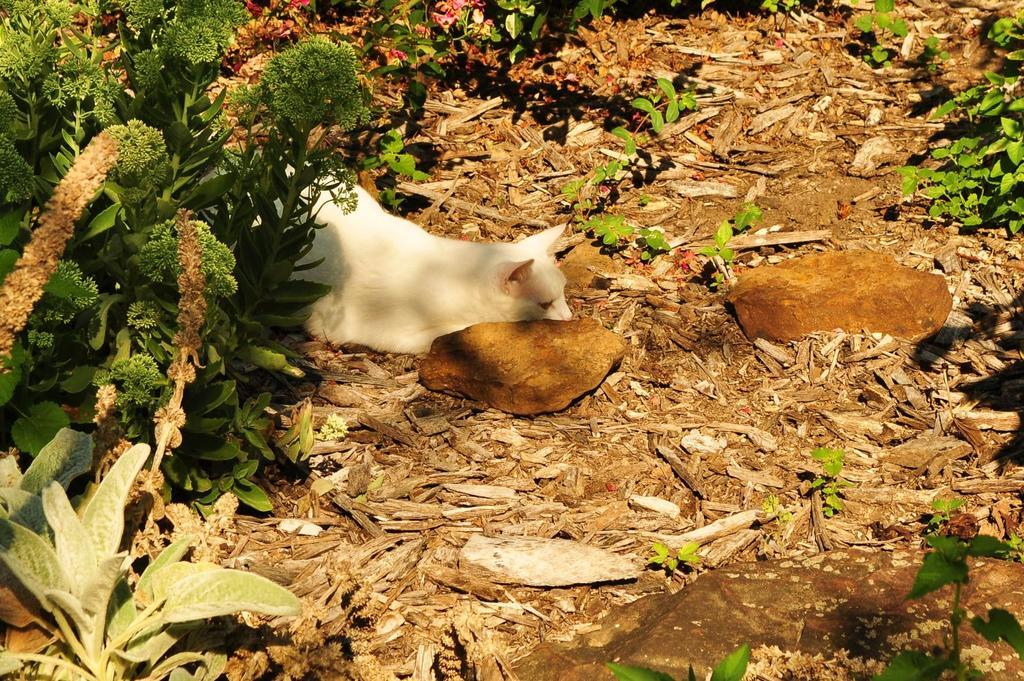What is the main subject in the middle of the image? There is a dog lying on the ground in the middle of the image. What can be seen in the background of the image? There are trees in the background of the image. What type of objects are present in the middle of the image besides the dog? There are stones in the middle of the image. Where is the nest located in the image? There is no nest present in the image. What type of fruit can be seen growing on the trees in the image? There is no fruit visible on the trees in the image. 